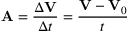<formula> <loc_0><loc_0><loc_500><loc_500>A = { \frac { \Delta V } { \Delta t } } = { \frac { V - V _ { 0 } } { t } }</formula> 